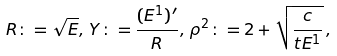Convert formula to latex. <formula><loc_0><loc_0><loc_500><loc_500>R \colon = \sqrt { E } , \, Y \colon = \frac { ( E ^ { 1 } ) ^ { \prime } } { R } , \, \rho ^ { 2 } \colon = 2 + \sqrt { \frac { c } { t E ^ { 1 } } } \, ,</formula> 